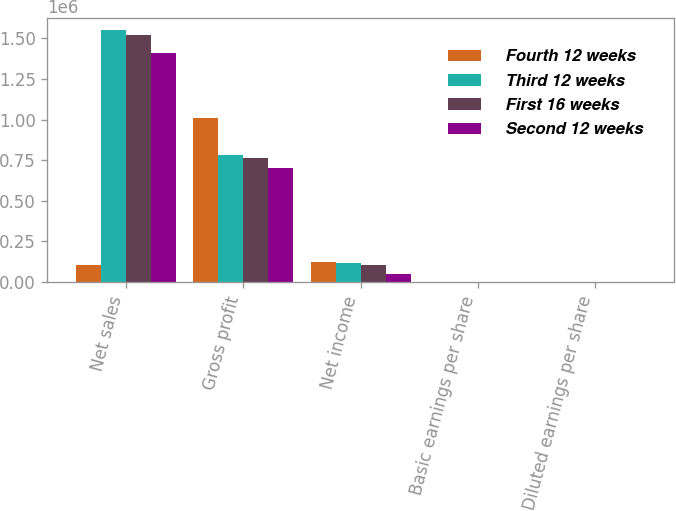<chart> <loc_0><loc_0><loc_500><loc_500><stacked_bar_chart><ecel><fcel>Net sales<fcel>Gross profit<fcel>Net income<fcel>Basic earnings per share<fcel>Diluted earnings per share<nl><fcel>Fourth 12 weeks<fcel>103830<fcel>1.00821e+06<fcel>121790<fcel>1.66<fcel>1.65<nl><fcel>Third 12 weeks<fcel>1.54955e+06<fcel>779223<fcel>116871<fcel>1.6<fcel>1.59<nl><fcel>First 16 weeks<fcel>1.52014e+06<fcel>762940<fcel>103830<fcel>1.42<fcel>1.42<nl><fcel>Second 12 weeks<fcel>1.40881e+06<fcel>701777<fcel>49267<fcel>0.68<fcel>0.67<nl></chart> 